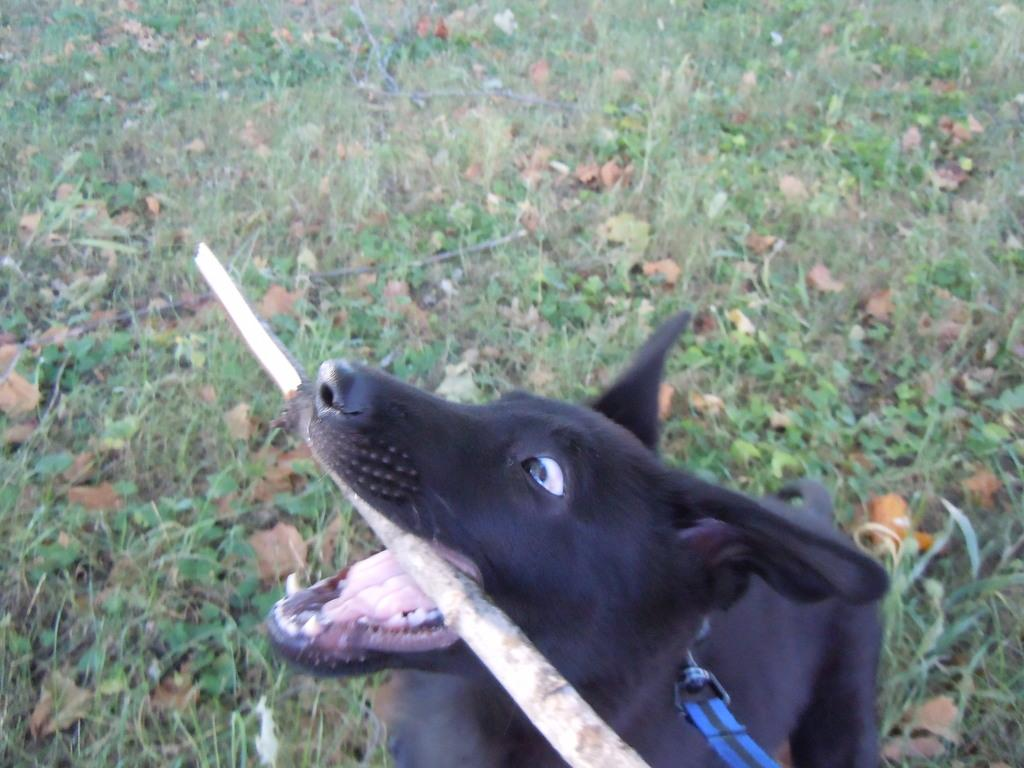What animal can be seen in the image? There is a dog in the image. What is the dog doing with its mouth? The dog is holding a stick in its mouth. Can you describe any accessory or clothing item in the image? There is a belt in the image. What type of natural elements are visible in the background of the image? There are plants and leaves present in the background of the image. What type of division is being performed by the monkey in the image? There is no monkey present in the image, so no division can be observed. What appliance is being used by the dog in the image? The dog is not using any appliance in the image; it is holding a stick in its mouth. 